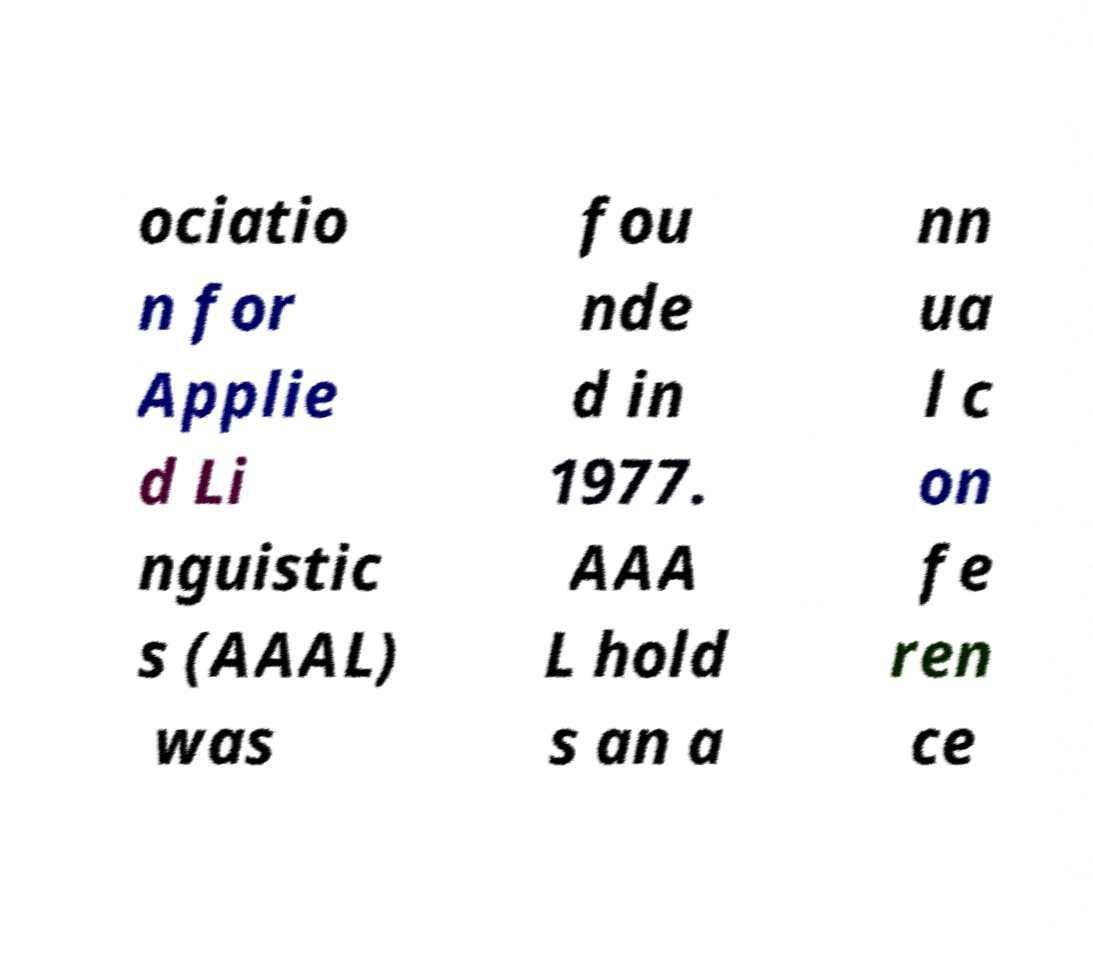I need the written content from this picture converted into text. Can you do that? ociatio n for Applie d Li nguistic s (AAAL) was fou nde d in 1977. AAA L hold s an a nn ua l c on fe ren ce 